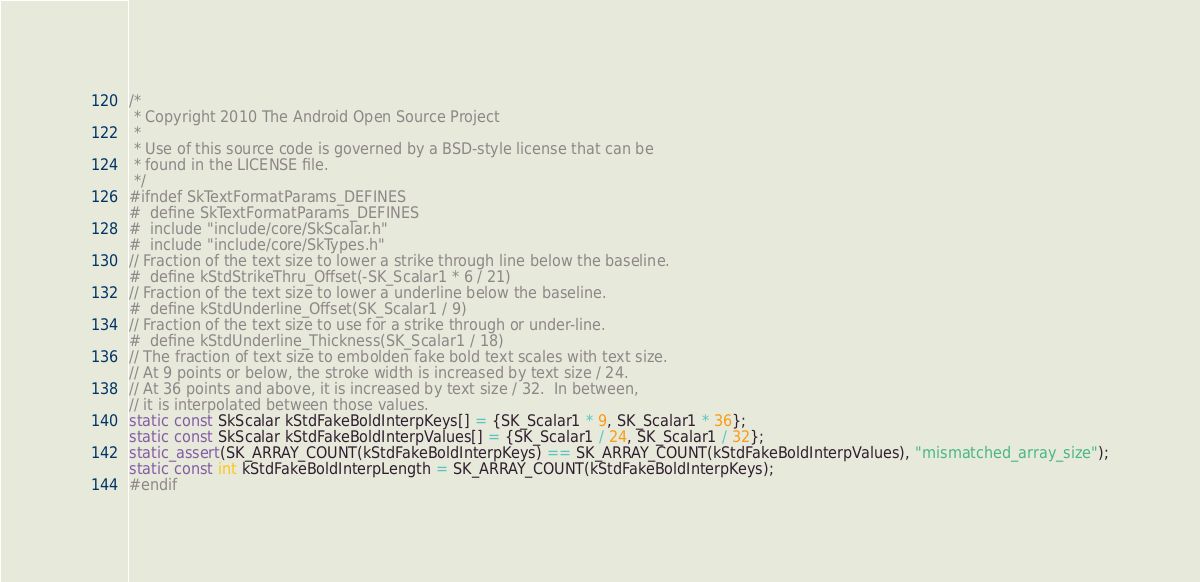Convert code to text. <code><loc_0><loc_0><loc_500><loc_500><_C_>/*
 * Copyright 2010 The Android Open Source Project
 *
 * Use of this source code is governed by a BSD-style license that can be
 * found in the LICENSE file.
 */
#ifndef SkTextFormatParams_DEFINES
#  define SkTextFormatParams_DEFINES
#  include "include/core/SkScalar.h"
#  include "include/core/SkTypes.h"
// Fraction of the text size to lower a strike through line below the baseline.
#  define kStdStrikeThru_Offset(-SK_Scalar1 * 6 / 21)
// Fraction of the text size to lower a underline below the baseline.
#  define kStdUnderline_Offset(SK_Scalar1 / 9)
// Fraction of the text size to use for a strike through or under-line.
#  define kStdUnderline_Thickness(SK_Scalar1 / 18)
// The fraction of text size to embolden fake bold text scales with text size.
// At 9 points or below, the stroke width is increased by text size / 24.
// At 36 points and above, it is increased by text size / 32.  In between,
// it is interpolated between those values.
static const SkScalar kStdFakeBoldInterpKeys[] = {SK_Scalar1 * 9, SK_Scalar1 * 36};
static const SkScalar kStdFakeBoldInterpValues[] = {SK_Scalar1 / 24, SK_Scalar1 / 32};
static_assert(SK_ARRAY_COUNT(kStdFakeBoldInterpKeys) == SK_ARRAY_COUNT(kStdFakeBoldInterpValues), "mismatched_array_size");
static const int kStdFakeBoldInterpLength = SK_ARRAY_COUNT(kStdFakeBoldInterpKeys);
#endif
</code> 